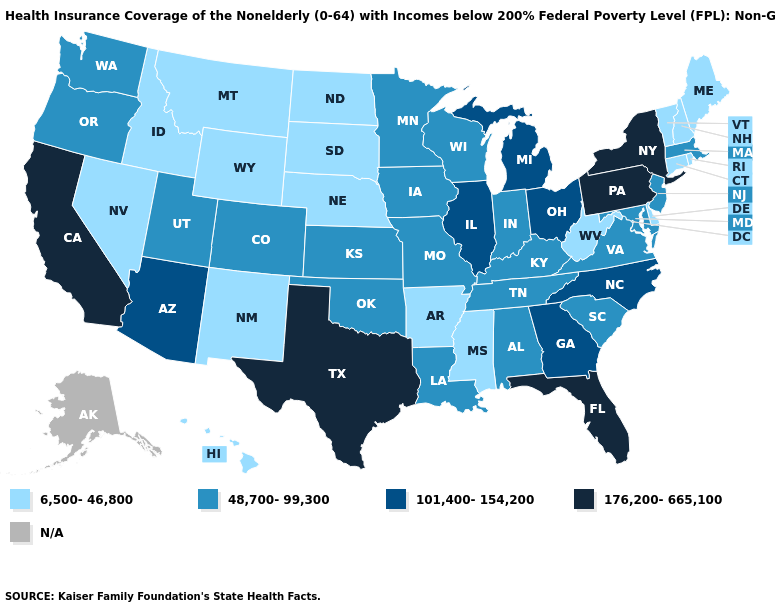What is the value of Hawaii?
Short answer required. 6,500-46,800. What is the highest value in the USA?
Quick response, please. 176,200-665,100. What is the highest value in the USA?
Keep it brief. 176,200-665,100. What is the value of Colorado?
Concise answer only. 48,700-99,300. Which states have the highest value in the USA?
Write a very short answer. California, Florida, New York, Pennsylvania, Texas. What is the highest value in states that border Montana?
Be succinct. 6,500-46,800. Does New York have the highest value in the USA?
Quick response, please. Yes. What is the lowest value in the USA?
Keep it brief. 6,500-46,800. Name the states that have a value in the range 176,200-665,100?
Give a very brief answer. California, Florida, New York, Pennsylvania, Texas. Name the states that have a value in the range 48,700-99,300?
Answer briefly. Alabama, Colorado, Indiana, Iowa, Kansas, Kentucky, Louisiana, Maryland, Massachusetts, Minnesota, Missouri, New Jersey, Oklahoma, Oregon, South Carolina, Tennessee, Utah, Virginia, Washington, Wisconsin. Among the states that border Rhode Island , does Massachusetts have the highest value?
Short answer required. Yes. What is the value of North Carolina?
Be succinct. 101,400-154,200. Name the states that have a value in the range N/A?
Give a very brief answer. Alaska. 